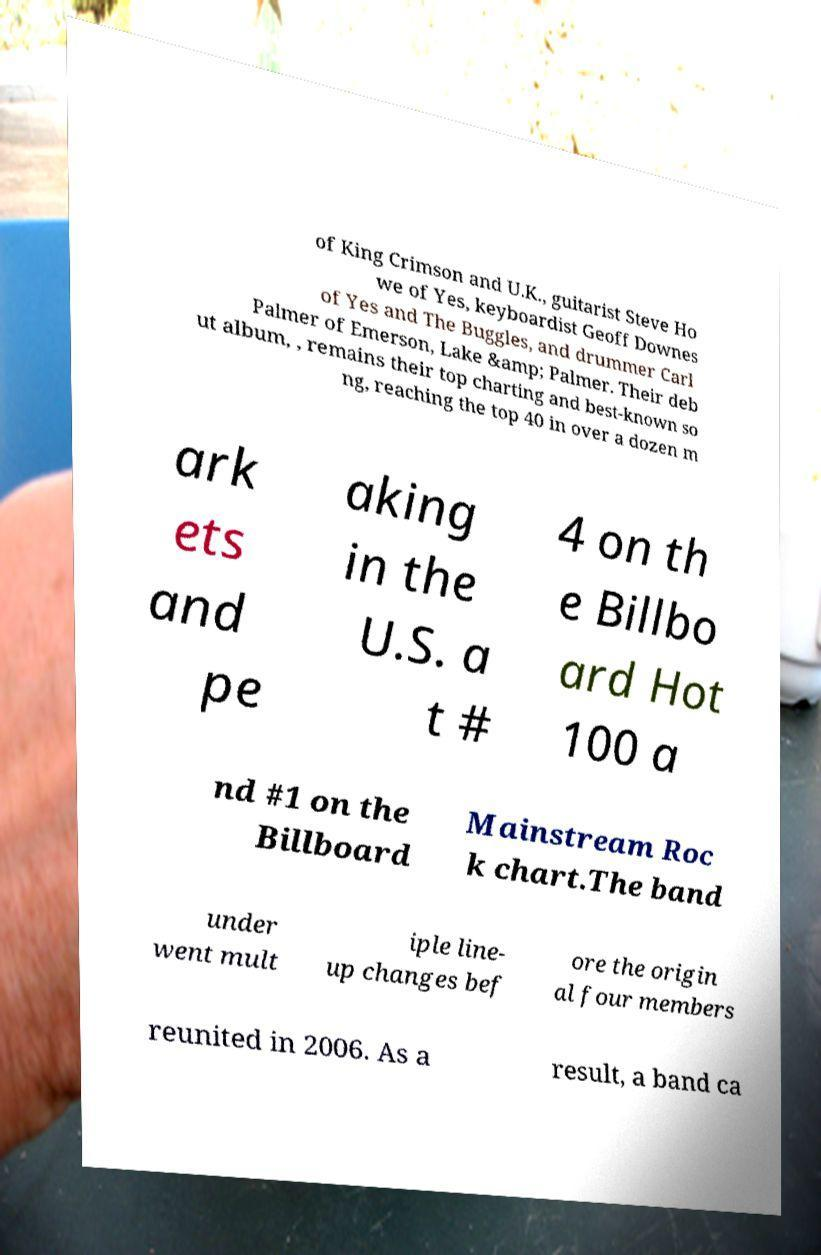I need the written content from this picture converted into text. Can you do that? of King Crimson and U.K., guitarist Steve Ho we of Yes, keyboardist Geoff Downes of Yes and The Buggles, and drummer Carl Palmer of Emerson, Lake &amp; Palmer. Their deb ut album, , remains their top charting and best-known so ng, reaching the top 40 in over a dozen m ark ets and pe aking in the U.S. a t # 4 on th e Billbo ard Hot 100 a nd #1 on the Billboard Mainstream Roc k chart.The band under went mult iple line- up changes bef ore the origin al four members reunited in 2006. As a result, a band ca 